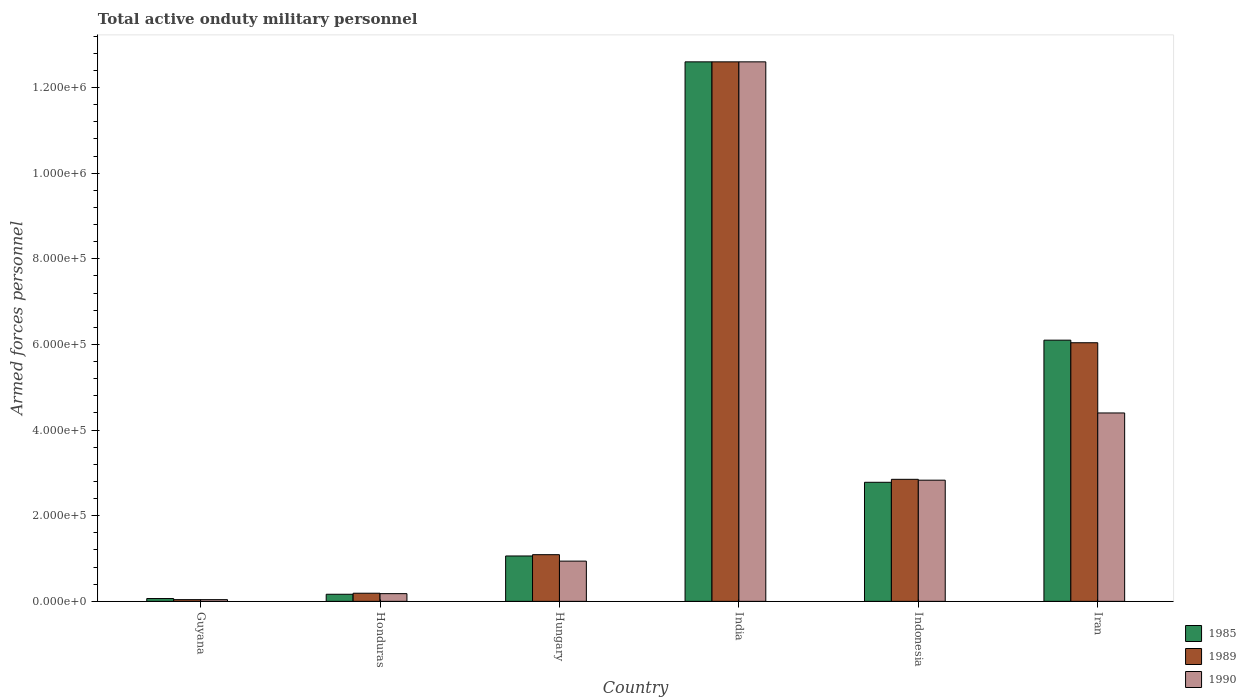How many different coloured bars are there?
Your answer should be compact. 3. Are the number of bars per tick equal to the number of legend labels?
Ensure brevity in your answer.  Yes. Are the number of bars on each tick of the X-axis equal?
Your response must be concise. Yes. How many bars are there on the 1st tick from the left?
Make the answer very short. 3. What is the label of the 2nd group of bars from the left?
Give a very brief answer. Honduras. What is the number of armed forces personnel in 1985 in Guyana?
Your answer should be compact. 6600. Across all countries, what is the maximum number of armed forces personnel in 1985?
Offer a very short reply. 1.26e+06. Across all countries, what is the minimum number of armed forces personnel in 1990?
Make the answer very short. 4000. In which country was the number of armed forces personnel in 1989 minimum?
Keep it short and to the point. Guyana. What is the total number of armed forces personnel in 1985 in the graph?
Offer a very short reply. 2.28e+06. What is the difference between the number of armed forces personnel in 1990 in Hungary and that in Indonesia?
Provide a short and direct response. -1.89e+05. What is the difference between the number of armed forces personnel in 1990 in India and the number of armed forces personnel in 1989 in Guyana?
Your answer should be compact. 1.26e+06. What is the average number of armed forces personnel in 1985 per country?
Keep it short and to the point. 3.80e+05. What is the difference between the number of armed forces personnel of/in 1989 and number of armed forces personnel of/in 1985 in Guyana?
Provide a short and direct response. -2600. What is the ratio of the number of armed forces personnel in 1990 in Guyana to that in Iran?
Offer a very short reply. 0.01. Is the number of armed forces personnel in 1985 in Hungary less than that in Iran?
Offer a terse response. Yes. What is the difference between the highest and the second highest number of armed forces personnel in 1989?
Make the answer very short. 9.75e+05. What is the difference between the highest and the lowest number of armed forces personnel in 1990?
Provide a short and direct response. 1.26e+06. In how many countries, is the number of armed forces personnel in 1985 greater than the average number of armed forces personnel in 1985 taken over all countries?
Keep it short and to the point. 2. Is the sum of the number of armed forces personnel in 1990 in Guyana and Honduras greater than the maximum number of armed forces personnel in 1989 across all countries?
Provide a succinct answer. No. What does the 1st bar from the right in Indonesia represents?
Your answer should be very brief. 1990. Does the graph contain grids?
Your answer should be very brief. No. How many legend labels are there?
Ensure brevity in your answer.  3. How are the legend labels stacked?
Your answer should be very brief. Vertical. What is the title of the graph?
Offer a very short reply. Total active onduty military personnel. Does "1963" appear as one of the legend labels in the graph?
Your answer should be very brief. No. What is the label or title of the Y-axis?
Provide a short and direct response. Armed forces personnel. What is the Armed forces personnel in 1985 in Guyana?
Provide a succinct answer. 6600. What is the Armed forces personnel of 1989 in Guyana?
Offer a very short reply. 4000. What is the Armed forces personnel in 1990 in Guyana?
Give a very brief answer. 4000. What is the Armed forces personnel in 1985 in Honduras?
Keep it short and to the point. 1.66e+04. What is the Armed forces personnel of 1989 in Honduras?
Give a very brief answer. 1.90e+04. What is the Armed forces personnel of 1990 in Honduras?
Give a very brief answer. 1.80e+04. What is the Armed forces personnel of 1985 in Hungary?
Offer a terse response. 1.06e+05. What is the Armed forces personnel of 1989 in Hungary?
Give a very brief answer. 1.09e+05. What is the Armed forces personnel in 1990 in Hungary?
Your answer should be very brief. 9.40e+04. What is the Armed forces personnel in 1985 in India?
Your answer should be very brief. 1.26e+06. What is the Armed forces personnel of 1989 in India?
Give a very brief answer. 1.26e+06. What is the Armed forces personnel in 1990 in India?
Your response must be concise. 1.26e+06. What is the Armed forces personnel in 1985 in Indonesia?
Give a very brief answer. 2.78e+05. What is the Armed forces personnel in 1989 in Indonesia?
Your response must be concise. 2.85e+05. What is the Armed forces personnel in 1990 in Indonesia?
Make the answer very short. 2.83e+05. What is the Armed forces personnel in 1985 in Iran?
Give a very brief answer. 6.10e+05. What is the Armed forces personnel in 1989 in Iran?
Offer a terse response. 6.04e+05. Across all countries, what is the maximum Armed forces personnel of 1985?
Provide a succinct answer. 1.26e+06. Across all countries, what is the maximum Armed forces personnel of 1989?
Offer a very short reply. 1.26e+06. Across all countries, what is the maximum Armed forces personnel of 1990?
Offer a terse response. 1.26e+06. Across all countries, what is the minimum Armed forces personnel in 1985?
Keep it short and to the point. 6600. Across all countries, what is the minimum Armed forces personnel in 1989?
Your response must be concise. 4000. Across all countries, what is the minimum Armed forces personnel of 1990?
Keep it short and to the point. 4000. What is the total Armed forces personnel in 1985 in the graph?
Make the answer very short. 2.28e+06. What is the total Armed forces personnel in 1989 in the graph?
Offer a very short reply. 2.28e+06. What is the total Armed forces personnel of 1990 in the graph?
Make the answer very short. 2.10e+06. What is the difference between the Armed forces personnel of 1989 in Guyana and that in Honduras?
Your response must be concise. -1.50e+04. What is the difference between the Armed forces personnel of 1990 in Guyana and that in Honduras?
Ensure brevity in your answer.  -1.40e+04. What is the difference between the Armed forces personnel of 1985 in Guyana and that in Hungary?
Offer a very short reply. -9.94e+04. What is the difference between the Armed forces personnel of 1989 in Guyana and that in Hungary?
Keep it short and to the point. -1.05e+05. What is the difference between the Armed forces personnel in 1990 in Guyana and that in Hungary?
Your answer should be compact. -9.00e+04. What is the difference between the Armed forces personnel in 1985 in Guyana and that in India?
Give a very brief answer. -1.25e+06. What is the difference between the Armed forces personnel in 1989 in Guyana and that in India?
Your response must be concise. -1.26e+06. What is the difference between the Armed forces personnel of 1990 in Guyana and that in India?
Your response must be concise. -1.26e+06. What is the difference between the Armed forces personnel of 1985 in Guyana and that in Indonesia?
Offer a terse response. -2.72e+05. What is the difference between the Armed forces personnel in 1989 in Guyana and that in Indonesia?
Offer a very short reply. -2.81e+05. What is the difference between the Armed forces personnel of 1990 in Guyana and that in Indonesia?
Offer a very short reply. -2.79e+05. What is the difference between the Armed forces personnel of 1985 in Guyana and that in Iran?
Your answer should be compact. -6.03e+05. What is the difference between the Armed forces personnel in 1989 in Guyana and that in Iran?
Give a very brief answer. -6.00e+05. What is the difference between the Armed forces personnel of 1990 in Guyana and that in Iran?
Make the answer very short. -4.36e+05. What is the difference between the Armed forces personnel in 1985 in Honduras and that in Hungary?
Your answer should be compact. -8.94e+04. What is the difference between the Armed forces personnel of 1990 in Honduras and that in Hungary?
Your response must be concise. -7.60e+04. What is the difference between the Armed forces personnel of 1985 in Honduras and that in India?
Keep it short and to the point. -1.24e+06. What is the difference between the Armed forces personnel of 1989 in Honduras and that in India?
Make the answer very short. -1.24e+06. What is the difference between the Armed forces personnel in 1990 in Honduras and that in India?
Your answer should be compact. -1.24e+06. What is the difference between the Armed forces personnel in 1985 in Honduras and that in Indonesia?
Provide a short and direct response. -2.62e+05. What is the difference between the Armed forces personnel in 1989 in Honduras and that in Indonesia?
Your answer should be very brief. -2.66e+05. What is the difference between the Armed forces personnel in 1990 in Honduras and that in Indonesia?
Make the answer very short. -2.65e+05. What is the difference between the Armed forces personnel of 1985 in Honduras and that in Iran?
Offer a terse response. -5.93e+05. What is the difference between the Armed forces personnel of 1989 in Honduras and that in Iran?
Your response must be concise. -5.85e+05. What is the difference between the Armed forces personnel of 1990 in Honduras and that in Iran?
Ensure brevity in your answer.  -4.22e+05. What is the difference between the Armed forces personnel in 1985 in Hungary and that in India?
Offer a terse response. -1.15e+06. What is the difference between the Armed forces personnel in 1989 in Hungary and that in India?
Provide a succinct answer. -1.15e+06. What is the difference between the Armed forces personnel of 1990 in Hungary and that in India?
Offer a very short reply. -1.17e+06. What is the difference between the Armed forces personnel of 1985 in Hungary and that in Indonesia?
Your response must be concise. -1.72e+05. What is the difference between the Armed forces personnel of 1989 in Hungary and that in Indonesia?
Provide a short and direct response. -1.76e+05. What is the difference between the Armed forces personnel in 1990 in Hungary and that in Indonesia?
Your answer should be compact. -1.89e+05. What is the difference between the Armed forces personnel in 1985 in Hungary and that in Iran?
Make the answer very short. -5.04e+05. What is the difference between the Armed forces personnel of 1989 in Hungary and that in Iran?
Give a very brief answer. -4.95e+05. What is the difference between the Armed forces personnel in 1990 in Hungary and that in Iran?
Provide a short and direct response. -3.46e+05. What is the difference between the Armed forces personnel in 1985 in India and that in Indonesia?
Offer a very short reply. 9.82e+05. What is the difference between the Armed forces personnel in 1989 in India and that in Indonesia?
Provide a succinct answer. 9.75e+05. What is the difference between the Armed forces personnel of 1990 in India and that in Indonesia?
Provide a short and direct response. 9.77e+05. What is the difference between the Armed forces personnel of 1985 in India and that in Iran?
Keep it short and to the point. 6.50e+05. What is the difference between the Armed forces personnel in 1989 in India and that in Iran?
Ensure brevity in your answer.  6.56e+05. What is the difference between the Armed forces personnel in 1990 in India and that in Iran?
Keep it short and to the point. 8.20e+05. What is the difference between the Armed forces personnel in 1985 in Indonesia and that in Iran?
Your answer should be very brief. -3.32e+05. What is the difference between the Armed forces personnel of 1989 in Indonesia and that in Iran?
Your answer should be very brief. -3.19e+05. What is the difference between the Armed forces personnel in 1990 in Indonesia and that in Iran?
Your answer should be very brief. -1.57e+05. What is the difference between the Armed forces personnel of 1985 in Guyana and the Armed forces personnel of 1989 in Honduras?
Offer a very short reply. -1.24e+04. What is the difference between the Armed forces personnel of 1985 in Guyana and the Armed forces personnel of 1990 in Honduras?
Offer a terse response. -1.14e+04. What is the difference between the Armed forces personnel in 1989 in Guyana and the Armed forces personnel in 1990 in Honduras?
Offer a very short reply. -1.40e+04. What is the difference between the Armed forces personnel in 1985 in Guyana and the Armed forces personnel in 1989 in Hungary?
Your response must be concise. -1.02e+05. What is the difference between the Armed forces personnel of 1985 in Guyana and the Armed forces personnel of 1990 in Hungary?
Your response must be concise. -8.74e+04. What is the difference between the Armed forces personnel of 1985 in Guyana and the Armed forces personnel of 1989 in India?
Keep it short and to the point. -1.25e+06. What is the difference between the Armed forces personnel of 1985 in Guyana and the Armed forces personnel of 1990 in India?
Keep it short and to the point. -1.25e+06. What is the difference between the Armed forces personnel of 1989 in Guyana and the Armed forces personnel of 1990 in India?
Provide a succinct answer. -1.26e+06. What is the difference between the Armed forces personnel in 1985 in Guyana and the Armed forces personnel in 1989 in Indonesia?
Offer a very short reply. -2.78e+05. What is the difference between the Armed forces personnel of 1985 in Guyana and the Armed forces personnel of 1990 in Indonesia?
Make the answer very short. -2.76e+05. What is the difference between the Armed forces personnel in 1989 in Guyana and the Armed forces personnel in 1990 in Indonesia?
Provide a short and direct response. -2.79e+05. What is the difference between the Armed forces personnel in 1985 in Guyana and the Armed forces personnel in 1989 in Iran?
Make the answer very short. -5.97e+05. What is the difference between the Armed forces personnel in 1985 in Guyana and the Armed forces personnel in 1990 in Iran?
Ensure brevity in your answer.  -4.33e+05. What is the difference between the Armed forces personnel in 1989 in Guyana and the Armed forces personnel in 1990 in Iran?
Provide a succinct answer. -4.36e+05. What is the difference between the Armed forces personnel of 1985 in Honduras and the Armed forces personnel of 1989 in Hungary?
Keep it short and to the point. -9.24e+04. What is the difference between the Armed forces personnel of 1985 in Honduras and the Armed forces personnel of 1990 in Hungary?
Ensure brevity in your answer.  -7.74e+04. What is the difference between the Armed forces personnel of 1989 in Honduras and the Armed forces personnel of 1990 in Hungary?
Provide a succinct answer. -7.50e+04. What is the difference between the Armed forces personnel of 1985 in Honduras and the Armed forces personnel of 1989 in India?
Provide a short and direct response. -1.24e+06. What is the difference between the Armed forces personnel in 1985 in Honduras and the Armed forces personnel in 1990 in India?
Offer a terse response. -1.24e+06. What is the difference between the Armed forces personnel in 1989 in Honduras and the Armed forces personnel in 1990 in India?
Make the answer very short. -1.24e+06. What is the difference between the Armed forces personnel of 1985 in Honduras and the Armed forces personnel of 1989 in Indonesia?
Keep it short and to the point. -2.68e+05. What is the difference between the Armed forces personnel of 1985 in Honduras and the Armed forces personnel of 1990 in Indonesia?
Ensure brevity in your answer.  -2.66e+05. What is the difference between the Armed forces personnel in 1989 in Honduras and the Armed forces personnel in 1990 in Indonesia?
Your answer should be very brief. -2.64e+05. What is the difference between the Armed forces personnel in 1985 in Honduras and the Armed forces personnel in 1989 in Iran?
Provide a succinct answer. -5.87e+05. What is the difference between the Armed forces personnel of 1985 in Honduras and the Armed forces personnel of 1990 in Iran?
Offer a very short reply. -4.23e+05. What is the difference between the Armed forces personnel of 1989 in Honduras and the Armed forces personnel of 1990 in Iran?
Your answer should be compact. -4.21e+05. What is the difference between the Armed forces personnel of 1985 in Hungary and the Armed forces personnel of 1989 in India?
Provide a succinct answer. -1.15e+06. What is the difference between the Armed forces personnel in 1985 in Hungary and the Armed forces personnel in 1990 in India?
Make the answer very short. -1.15e+06. What is the difference between the Armed forces personnel in 1989 in Hungary and the Armed forces personnel in 1990 in India?
Your answer should be very brief. -1.15e+06. What is the difference between the Armed forces personnel of 1985 in Hungary and the Armed forces personnel of 1989 in Indonesia?
Make the answer very short. -1.79e+05. What is the difference between the Armed forces personnel in 1985 in Hungary and the Armed forces personnel in 1990 in Indonesia?
Your answer should be compact. -1.77e+05. What is the difference between the Armed forces personnel of 1989 in Hungary and the Armed forces personnel of 1990 in Indonesia?
Your answer should be compact. -1.74e+05. What is the difference between the Armed forces personnel of 1985 in Hungary and the Armed forces personnel of 1989 in Iran?
Your response must be concise. -4.98e+05. What is the difference between the Armed forces personnel in 1985 in Hungary and the Armed forces personnel in 1990 in Iran?
Your response must be concise. -3.34e+05. What is the difference between the Armed forces personnel of 1989 in Hungary and the Armed forces personnel of 1990 in Iran?
Provide a succinct answer. -3.31e+05. What is the difference between the Armed forces personnel in 1985 in India and the Armed forces personnel in 1989 in Indonesia?
Provide a succinct answer. 9.75e+05. What is the difference between the Armed forces personnel in 1985 in India and the Armed forces personnel in 1990 in Indonesia?
Offer a very short reply. 9.77e+05. What is the difference between the Armed forces personnel of 1989 in India and the Armed forces personnel of 1990 in Indonesia?
Provide a short and direct response. 9.77e+05. What is the difference between the Armed forces personnel in 1985 in India and the Armed forces personnel in 1989 in Iran?
Give a very brief answer. 6.56e+05. What is the difference between the Armed forces personnel in 1985 in India and the Armed forces personnel in 1990 in Iran?
Make the answer very short. 8.20e+05. What is the difference between the Armed forces personnel in 1989 in India and the Armed forces personnel in 1990 in Iran?
Offer a terse response. 8.20e+05. What is the difference between the Armed forces personnel in 1985 in Indonesia and the Armed forces personnel in 1989 in Iran?
Keep it short and to the point. -3.26e+05. What is the difference between the Armed forces personnel of 1985 in Indonesia and the Armed forces personnel of 1990 in Iran?
Offer a terse response. -1.62e+05. What is the difference between the Armed forces personnel of 1989 in Indonesia and the Armed forces personnel of 1990 in Iran?
Your answer should be compact. -1.55e+05. What is the average Armed forces personnel of 1985 per country?
Your response must be concise. 3.80e+05. What is the average Armed forces personnel in 1989 per country?
Offer a very short reply. 3.80e+05. What is the average Armed forces personnel of 1990 per country?
Ensure brevity in your answer.  3.50e+05. What is the difference between the Armed forces personnel of 1985 and Armed forces personnel of 1989 in Guyana?
Offer a terse response. 2600. What is the difference between the Armed forces personnel in 1985 and Armed forces personnel in 1990 in Guyana?
Your answer should be very brief. 2600. What is the difference between the Armed forces personnel of 1985 and Armed forces personnel of 1989 in Honduras?
Offer a very short reply. -2400. What is the difference between the Armed forces personnel of 1985 and Armed forces personnel of 1990 in Honduras?
Provide a succinct answer. -1400. What is the difference between the Armed forces personnel in 1985 and Armed forces personnel in 1989 in Hungary?
Ensure brevity in your answer.  -3000. What is the difference between the Armed forces personnel in 1985 and Armed forces personnel in 1990 in Hungary?
Make the answer very short. 1.20e+04. What is the difference between the Armed forces personnel in 1989 and Armed forces personnel in 1990 in Hungary?
Offer a very short reply. 1.50e+04. What is the difference between the Armed forces personnel in 1985 and Armed forces personnel in 1989 in India?
Keep it short and to the point. 0. What is the difference between the Armed forces personnel in 1985 and Armed forces personnel in 1990 in India?
Your answer should be very brief. 0. What is the difference between the Armed forces personnel of 1985 and Armed forces personnel of 1989 in Indonesia?
Ensure brevity in your answer.  -6900. What is the difference between the Armed forces personnel in 1985 and Armed forces personnel in 1990 in Indonesia?
Your response must be concise. -4900. What is the difference between the Armed forces personnel in 1985 and Armed forces personnel in 1989 in Iran?
Your answer should be very brief. 6000. What is the difference between the Armed forces personnel of 1989 and Armed forces personnel of 1990 in Iran?
Provide a succinct answer. 1.64e+05. What is the ratio of the Armed forces personnel in 1985 in Guyana to that in Honduras?
Ensure brevity in your answer.  0.4. What is the ratio of the Armed forces personnel in 1989 in Guyana to that in Honduras?
Give a very brief answer. 0.21. What is the ratio of the Armed forces personnel in 1990 in Guyana to that in Honduras?
Your response must be concise. 0.22. What is the ratio of the Armed forces personnel in 1985 in Guyana to that in Hungary?
Offer a very short reply. 0.06. What is the ratio of the Armed forces personnel in 1989 in Guyana to that in Hungary?
Keep it short and to the point. 0.04. What is the ratio of the Armed forces personnel in 1990 in Guyana to that in Hungary?
Your response must be concise. 0.04. What is the ratio of the Armed forces personnel of 1985 in Guyana to that in India?
Your answer should be very brief. 0.01. What is the ratio of the Armed forces personnel in 1989 in Guyana to that in India?
Make the answer very short. 0. What is the ratio of the Armed forces personnel in 1990 in Guyana to that in India?
Offer a very short reply. 0. What is the ratio of the Armed forces personnel in 1985 in Guyana to that in Indonesia?
Your answer should be compact. 0.02. What is the ratio of the Armed forces personnel in 1989 in Guyana to that in Indonesia?
Make the answer very short. 0.01. What is the ratio of the Armed forces personnel in 1990 in Guyana to that in Indonesia?
Your response must be concise. 0.01. What is the ratio of the Armed forces personnel of 1985 in Guyana to that in Iran?
Ensure brevity in your answer.  0.01. What is the ratio of the Armed forces personnel in 1989 in Guyana to that in Iran?
Provide a short and direct response. 0.01. What is the ratio of the Armed forces personnel of 1990 in Guyana to that in Iran?
Offer a terse response. 0.01. What is the ratio of the Armed forces personnel of 1985 in Honduras to that in Hungary?
Give a very brief answer. 0.16. What is the ratio of the Armed forces personnel in 1989 in Honduras to that in Hungary?
Provide a short and direct response. 0.17. What is the ratio of the Armed forces personnel in 1990 in Honduras to that in Hungary?
Provide a succinct answer. 0.19. What is the ratio of the Armed forces personnel of 1985 in Honduras to that in India?
Keep it short and to the point. 0.01. What is the ratio of the Armed forces personnel of 1989 in Honduras to that in India?
Ensure brevity in your answer.  0.02. What is the ratio of the Armed forces personnel of 1990 in Honduras to that in India?
Make the answer very short. 0.01. What is the ratio of the Armed forces personnel of 1985 in Honduras to that in Indonesia?
Provide a short and direct response. 0.06. What is the ratio of the Armed forces personnel of 1989 in Honduras to that in Indonesia?
Your response must be concise. 0.07. What is the ratio of the Armed forces personnel of 1990 in Honduras to that in Indonesia?
Ensure brevity in your answer.  0.06. What is the ratio of the Armed forces personnel of 1985 in Honduras to that in Iran?
Give a very brief answer. 0.03. What is the ratio of the Armed forces personnel of 1989 in Honduras to that in Iran?
Your answer should be compact. 0.03. What is the ratio of the Armed forces personnel of 1990 in Honduras to that in Iran?
Give a very brief answer. 0.04. What is the ratio of the Armed forces personnel in 1985 in Hungary to that in India?
Ensure brevity in your answer.  0.08. What is the ratio of the Armed forces personnel of 1989 in Hungary to that in India?
Ensure brevity in your answer.  0.09. What is the ratio of the Armed forces personnel of 1990 in Hungary to that in India?
Give a very brief answer. 0.07. What is the ratio of the Armed forces personnel in 1985 in Hungary to that in Indonesia?
Offer a very short reply. 0.38. What is the ratio of the Armed forces personnel of 1989 in Hungary to that in Indonesia?
Keep it short and to the point. 0.38. What is the ratio of the Armed forces personnel of 1990 in Hungary to that in Indonesia?
Make the answer very short. 0.33. What is the ratio of the Armed forces personnel of 1985 in Hungary to that in Iran?
Provide a short and direct response. 0.17. What is the ratio of the Armed forces personnel of 1989 in Hungary to that in Iran?
Make the answer very short. 0.18. What is the ratio of the Armed forces personnel of 1990 in Hungary to that in Iran?
Give a very brief answer. 0.21. What is the ratio of the Armed forces personnel in 1985 in India to that in Indonesia?
Provide a succinct answer. 4.53. What is the ratio of the Armed forces personnel in 1989 in India to that in Indonesia?
Offer a terse response. 4.42. What is the ratio of the Armed forces personnel of 1990 in India to that in Indonesia?
Your response must be concise. 4.45. What is the ratio of the Armed forces personnel in 1985 in India to that in Iran?
Make the answer very short. 2.07. What is the ratio of the Armed forces personnel in 1989 in India to that in Iran?
Provide a short and direct response. 2.09. What is the ratio of the Armed forces personnel of 1990 in India to that in Iran?
Give a very brief answer. 2.86. What is the ratio of the Armed forces personnel of 1985 in Indonesia to that in Iran?
Make the answer very short. 0.46. What is the ratio of the Armed forces personnel in 1989 in Indonesia to that in Iran?
Provide a short and direct response. 0.47. What is the ratio of the Armed forces personnel of 1990 in Indonesia to that in Iran?
Ensure brevity in your answer.  0.64. What is the difference between the highest and the second highest Armed forces personnel in 1985?
Give a very brief answer. 6.50e+05. What is the difference between the highest and the second highest Armed forces personnel in 1989?
Keep it short and to the point. 6.56e+05. What is the difference between the highest and the second highest Armed forces personnel in 1990?
Offer a very short reply. 8.20e+05. What is the difference between the highest and the lowest Armed forces personnel of 1985?
Make the answer very short. 1.25e+06. What is the difference between the highest and the lowest Armed forces personnel of 1989?
Offer a very short reply. 1.26e+06. What is the difference between the highest and the lowest Armed forces personnel of 1990?
Ensure brevity in your answer.  1.26e+06. 